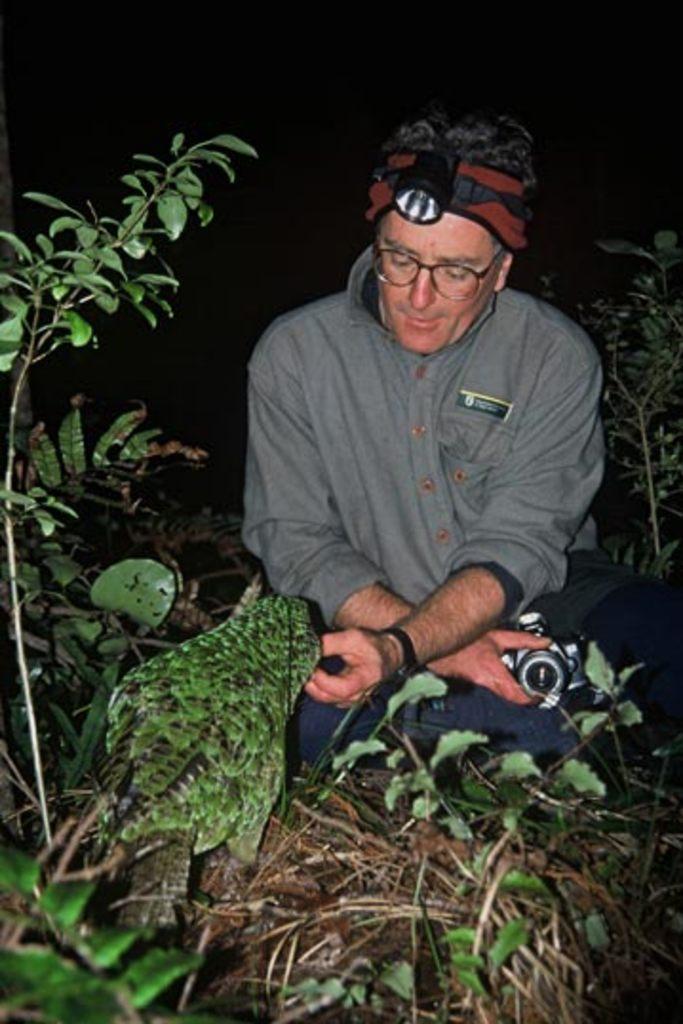How would you summarize this image in a sentence or two? In this image, we can see a person wearing glasses and a headlamp and he is holding an object. In the background, there are plants and we can see a bird. 